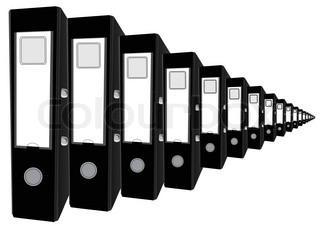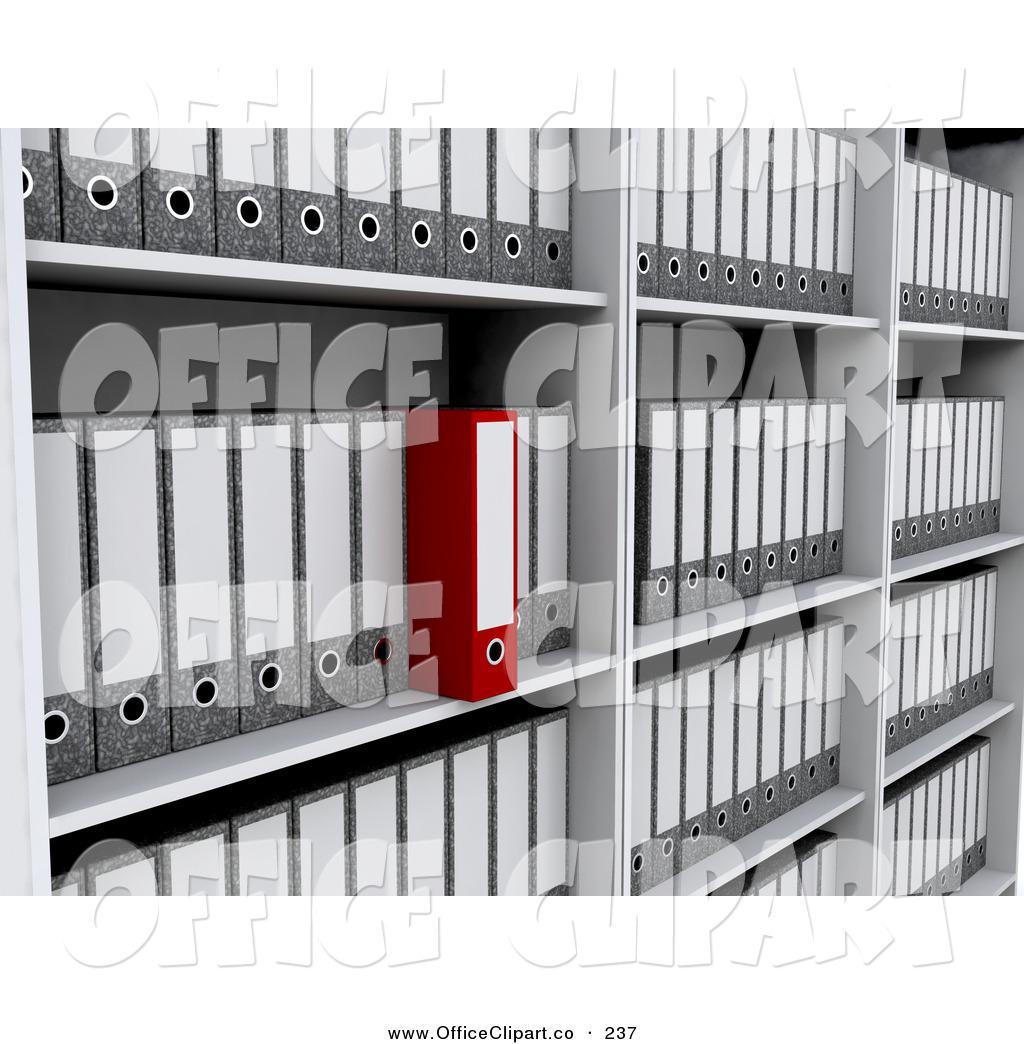The first image is the image on the left, the second image is the image on the right. Evaluate the accuracy of this statement regarding the images: "One image shows a binder both open and closed, while the other image shows a closed binder in two to four color options.". Is it true? Answer yes or no. No. 